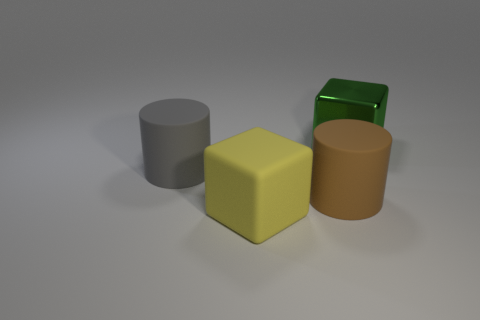Add 1 big matte things. How many objects exist? 5 Add 2 large yellow rubber blocks. How many large yellow rubber blocks exist? 3 Subtract 0 yellow spheres. How many objects are left? 4 Subtract all brown rubber things. Subtract all green things. How many objects are left? 2 Add 1 yellow objects. How many yellow objects are left? 2 